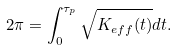Convert formula to latex. <formula><loc_0><loc_0><loc_500><loc_500>2 \pi = \int _ { 0 } ^ { \tau _ { p } } \sqrt { K _ { e f f } ( t ) } d t .</formula> 